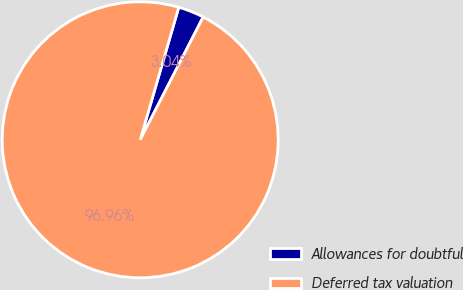<chart> <loc_0><loc_0><loc_500><loc_500><pie_chart><fcel>Allowances for doubtful<fcel>Deferred tax valuation<nl><fcel>3.04%<fcel>96.96%<nl></chart> 